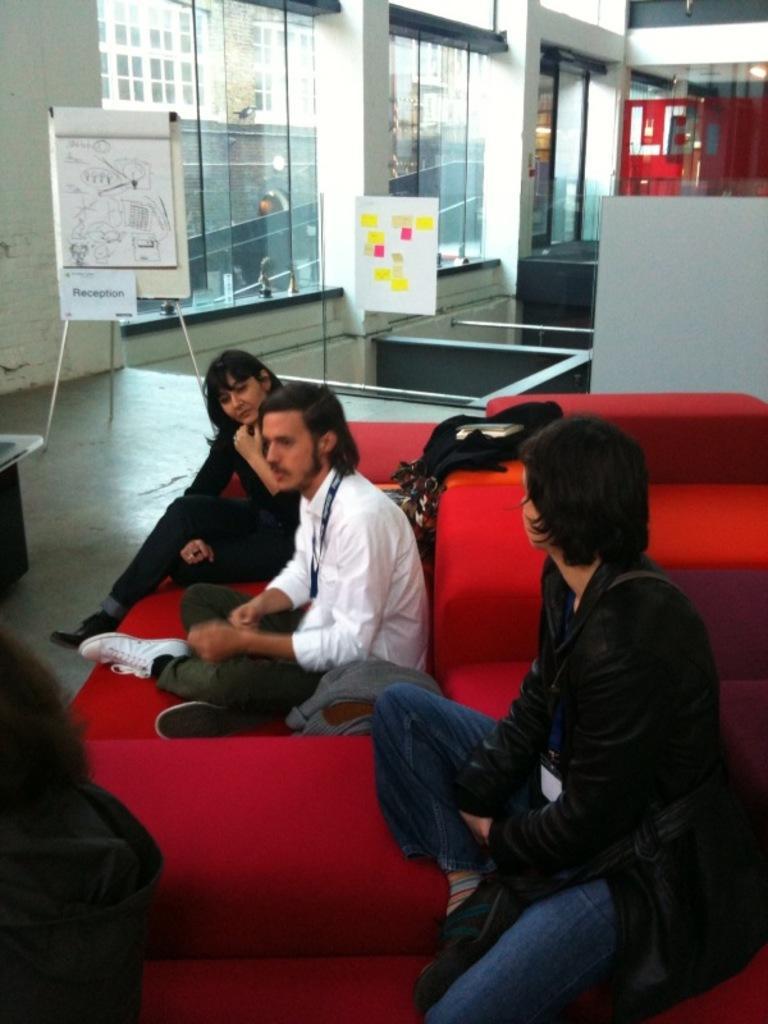Describe this image in one or two sentences. There are people sitting in the foreground area of the image, there are glass windows, buildings, a board and other objects in the background. 